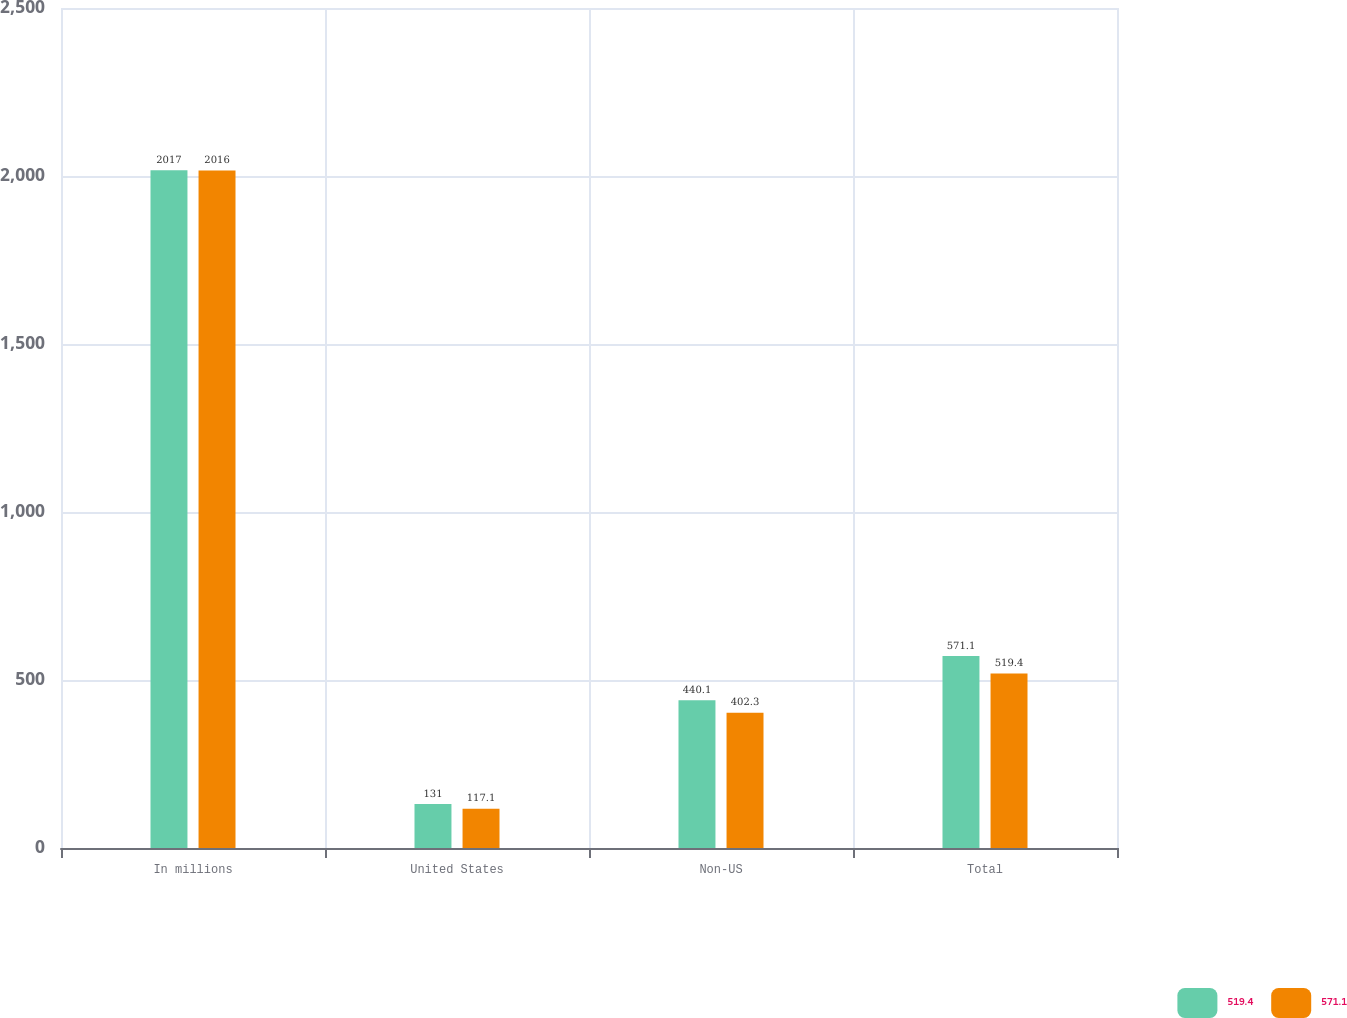Convert chart to OTSL. <chart><loc_0><loc_0><loc_500><loc_500><stacked_bar_chart><ecel><fcel>In millions<fcel>United States<fcel>Non-US<fcel>Total<nl><fcel>519.4<fcel>2017<fcel>131<fcel>440.1<fcel>571.1<nl><fcel>571.1<fcel>2016<fcel>117.1<fcel>402.3<fcel>519.4<nl></chart> 